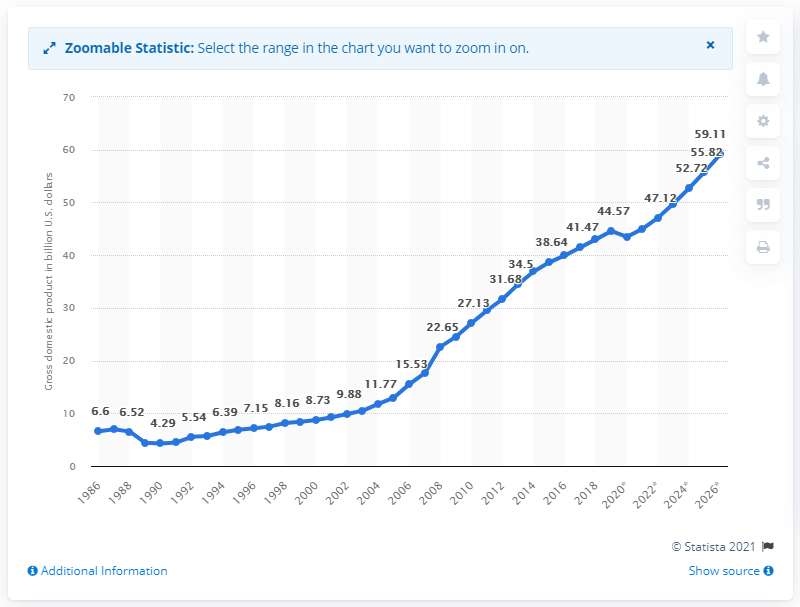Identify some key points in this picture. In 2019, Jordan's gross domestic product (GDP) was approximately 44.98 billion dollars. 